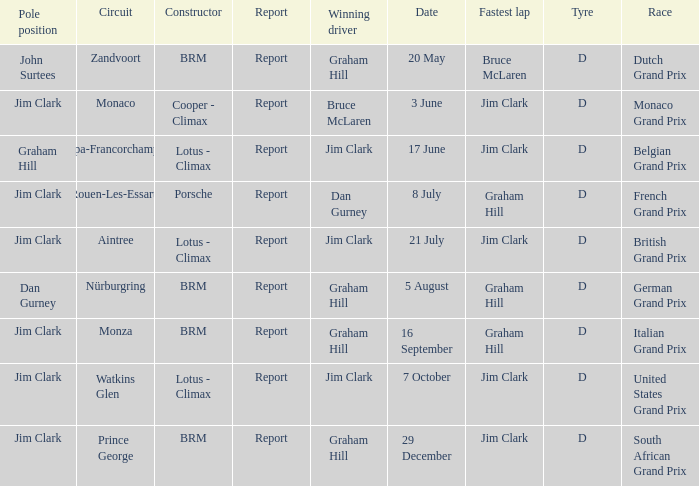What is the tyre on the race where Bruce Mclaren had the fastest lap? D. 